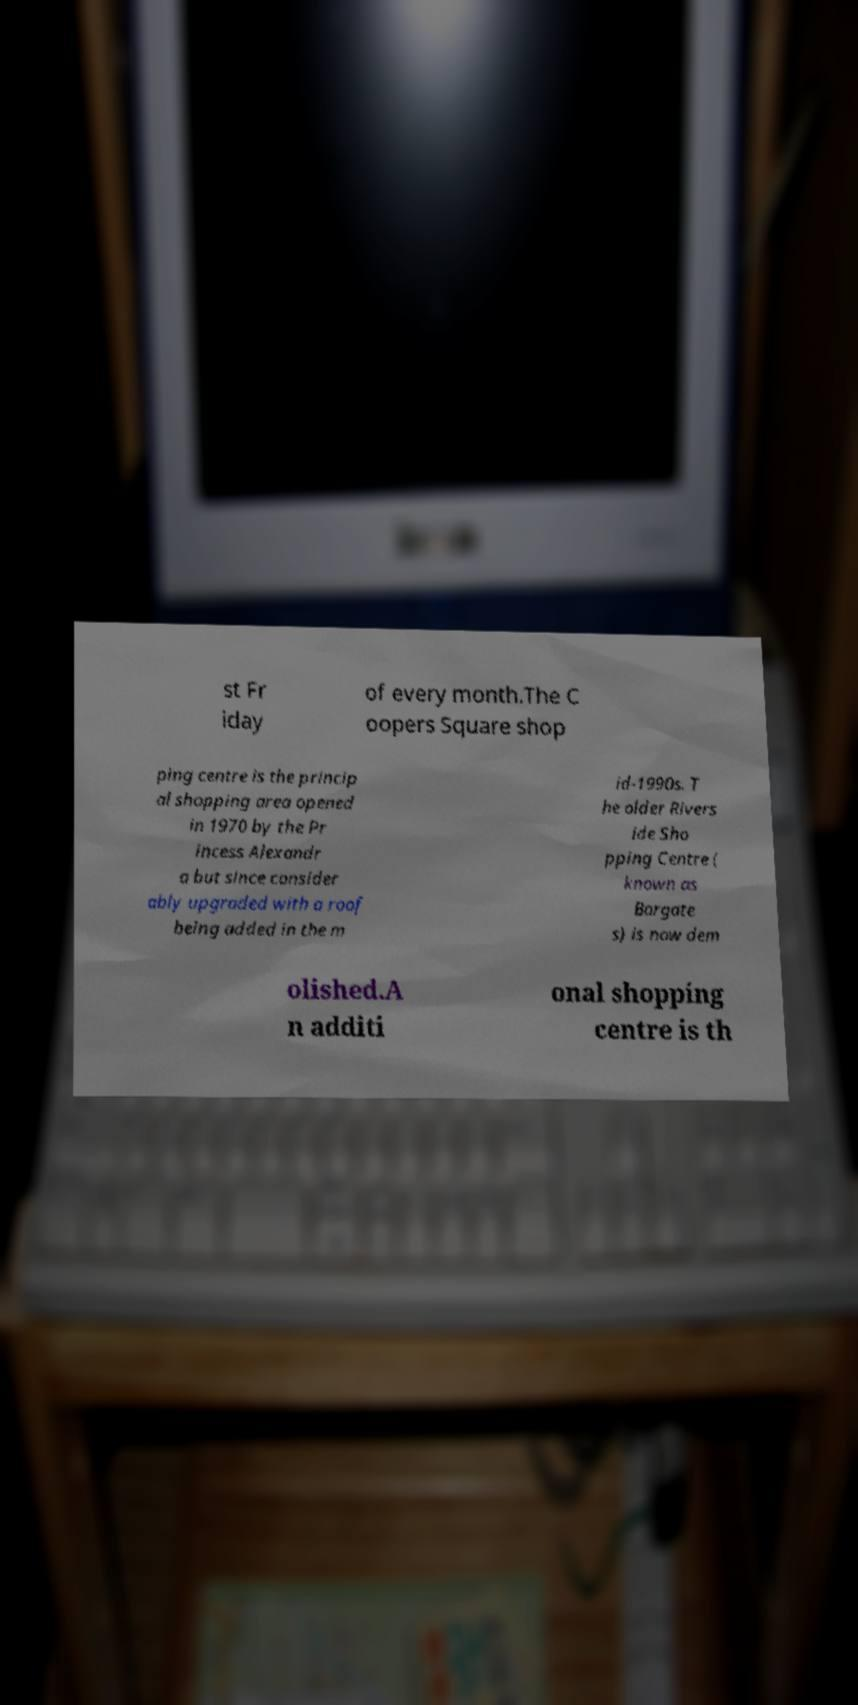Could you extract and type out the text from this image? st Fr iday of every month.The C oopers Square shop ping centre is the princip al shopping area opened in 1970 by the Pr incess Alexandr a but since consider ably upgraded with a roof being added in the m id-1990s. T he older Rivers ide Sho pping Centre ( known as Bargate s) is now dem olished.A n additi onal shopping centre is th 